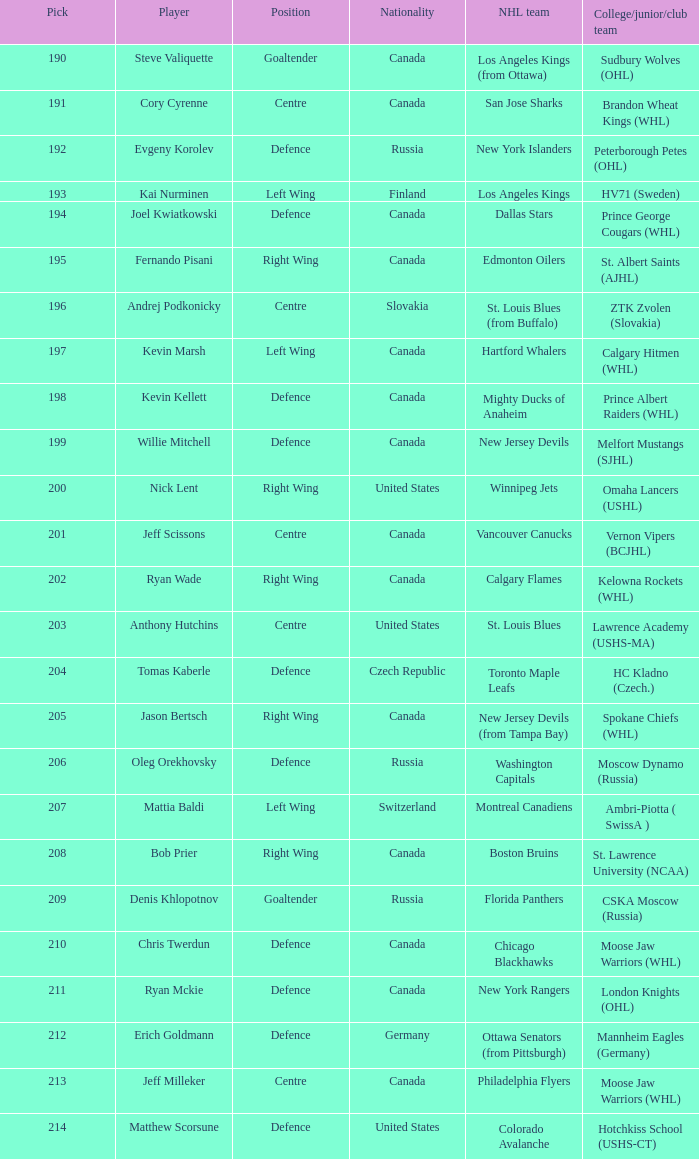Would you be able to parse every entry in this table? {'header': ['Pick', 'Player', 'Position', 'Nationality', 'NHL team', 'College/junior/club team'], 'rows': [['190', 'Steve Valiquette', 'Goaltender', 'Canada', 'Los Angeles Kings (from Ottawa)', 'Sudbury Wolves (OHL)'], ['191', 'Cory Cyrenne', 'Centre', 'Canada', 'San Jose Sharks', 'Brandon Wheat Kings (WHL)'], ['192', 'Evgeny Korolev', 'Defence', 'Russia', 'New York Islanders', 'Peterborough Petes (OHL)'], ['193', 'Kai Nurminen', 'Left Wing', 'Finland', 'Los Angeles Kings', 'HV71 (Sweden)'], ['194', 'Joel Kwiatkowski', 'Defence', 'Canada', 'Dallas Stars', 'Prince George Cougars (WHL)'], ['195', 'Fernando Pisani', 'Right Wing', 'Canada', 'Edmonton Oilers', 'St. Albert Saints (AJHL)'], ['196', 'Andrej Podkonicky', 'Centre', 'Slovakia', 'St. Louis Blues (from Buffalo)', 'ZTK Zvolen (Slovakia)'], ['197', 'Kevin Marsh', 'Left Wing', 'Canada', 'Hartford Whalers', 'Calgary Hitmen (WHL)'], ['198', 'Kevin Kellett', 'Defence', 'Canada', 'Mighty Ducks of Anaheim', 'Prince Albert Raiders (WHL)'], ['199', 'Willie Mitchell', 'Defence', 'Canada', 'New Jersey Devils', 'Melfort Mustangs (SJHL)'], ['200', 'Nick Lent', 'Right Wing', 'United States', 'Winnipeg Jets', 'Omaha Lancers (USHL)'], ['201', 'Jeff Scissons', 'Centre', 'Canada', 'Vancouver Canucks', 'Vernon Vipers (BCJHL)'], ['202', 'Ryan Wade', 'Right Wing', 'Canada', 'Calgary Flames', 'Kelowna Rockets (WHL)'], ['203', 'Anthony Hutchins', 'Centre', 'United States', 'St. Louis Blues', 'Lawrence Academy (USHS-MA)'], ['204', 'Tomas Kaberle', 'Defence', 'Czech Republic', 'Toronto Maple Leafs', 'HC Kladno (Czech.)'], ['205', 'Jason Bertsch', 'Right Wing', 'Canada', 'New Jersey Devils (from Tampa Bay)', 'Spokane Chiefs (WHL)'], ['206', 'Oleg Orekhovsky', 'Defence', 'Russia', 'Washington Capitals', 'Moscow Dynamo (Russia)'], ['207', 'Mattia Baldi', 'Left Wing', 'Switzerland', 'Montreal Canadiens', 'Ambri-Piotta ( SwissA )'], ['208', 'Bob Prier', 'Right Wing', 'Canada', 'Boston Bruins', 'St. Lawrence University (NCAA)'], ['209', 'Denis Khlopotnov', 'Goaltender', 'Russia', 'Florida Panthers', 'CSKA Moscow (Russia)'], ['210', 'Chris Twerdun', 'Defence', 'Canada', 'Chicago Blackhawks', 'Moose Jaw Warriors (WHL)'], ['211', 'Ryan Mckie', 'Defence', 'Canada', 'New York Rangers', 'London Knights (OHL)'], ['212', 'Erich Goldmann', 'Defence', 'Germany', 'Ottawa Senators (from Pittsburgh)', 'Mannheim Eagles (Germany)'], ['213', 'Jeff Milleker', 'Centre', 'Canada', 'Philadelphia Flyers', 'Moose Jaw Warriors (WHL)'], ['214', 'Matthew Scorsune', 'Defence', 'United States', 'Colorado Avalanche', 'Hotchkiss School (USHS-CT)']]} Name the most pick for evgeny korolev 192.0. 